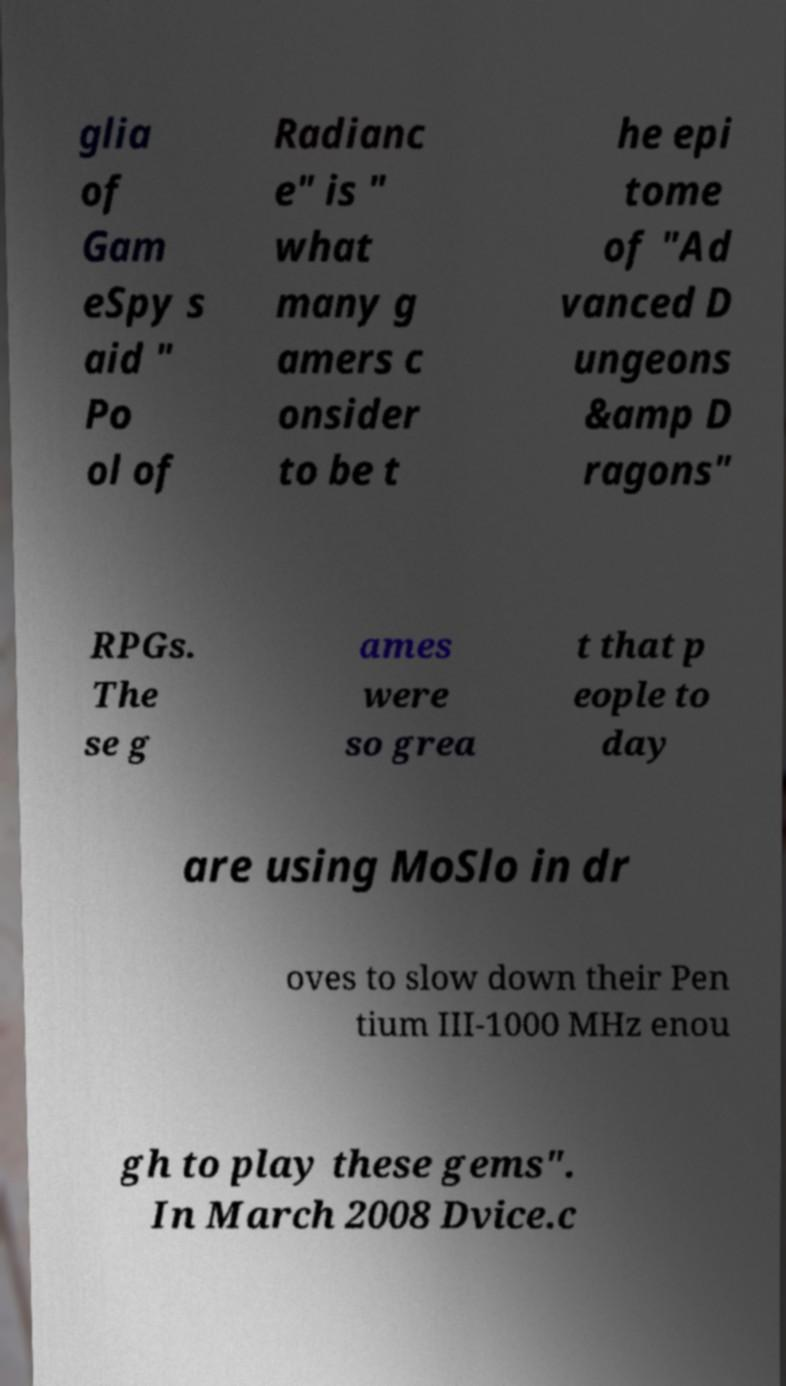Can you read and provide the text displayed in the image?This photo seems to have some interesting text. Can you extract and type it out for me? glia of Gam eSpy s aid " Po ol of Radianc e" is " what many g amers c onsider to be t he epi tome of "Ad vanced D ungeons &amp D ragons" RPGs. The se g ames were so grea t that p eople to day are using MoSlo in dr oves to slow down their Pen tium III-1000 MHz enou gh to play these gems". In March 2008 Dvice.c 